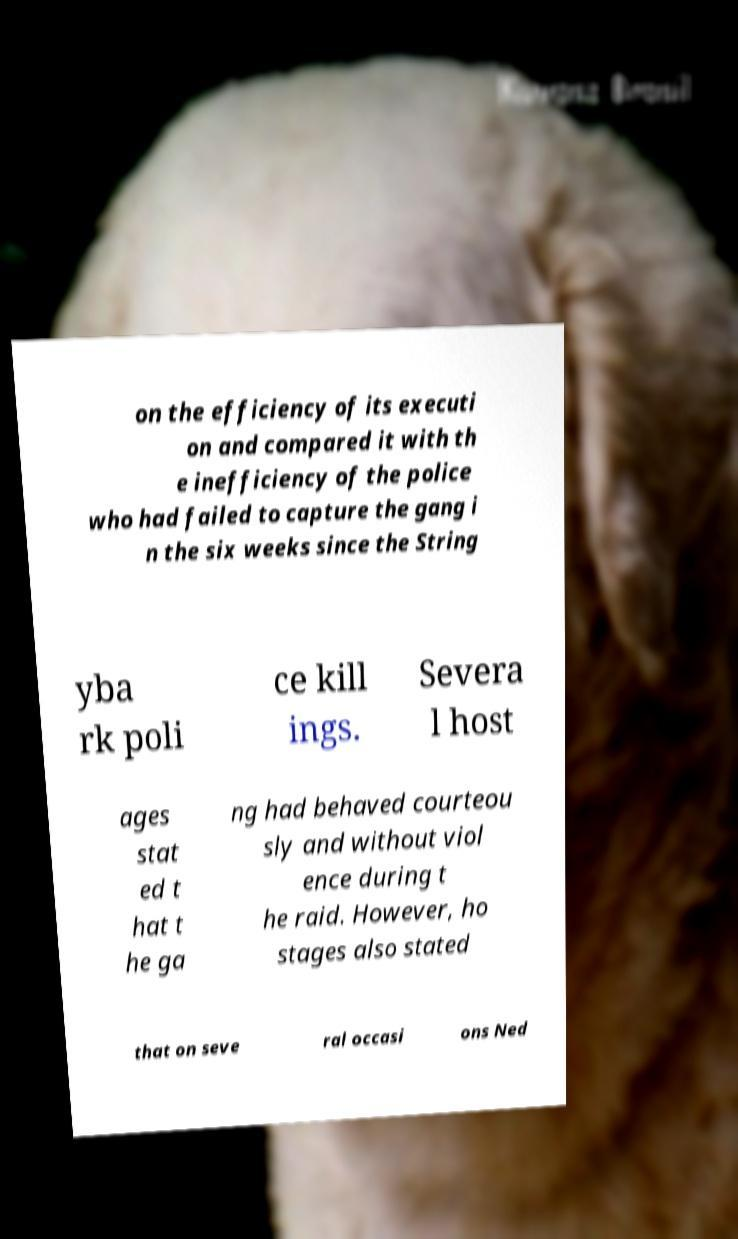What messages or text are displayed in this image? I need them in a readable, typed format. on the efficiency of its executi on and compared it with th e inefficiency of the police who had failed to capture the gang i n the six weeks since the String yba rk poli ce kill ings. Severa l host ages stat ed t hat t he ga ng had behaved courteou sly and without viol ence during t he raid. However, ho stages also stated that on seve ral occasi ons Ned 